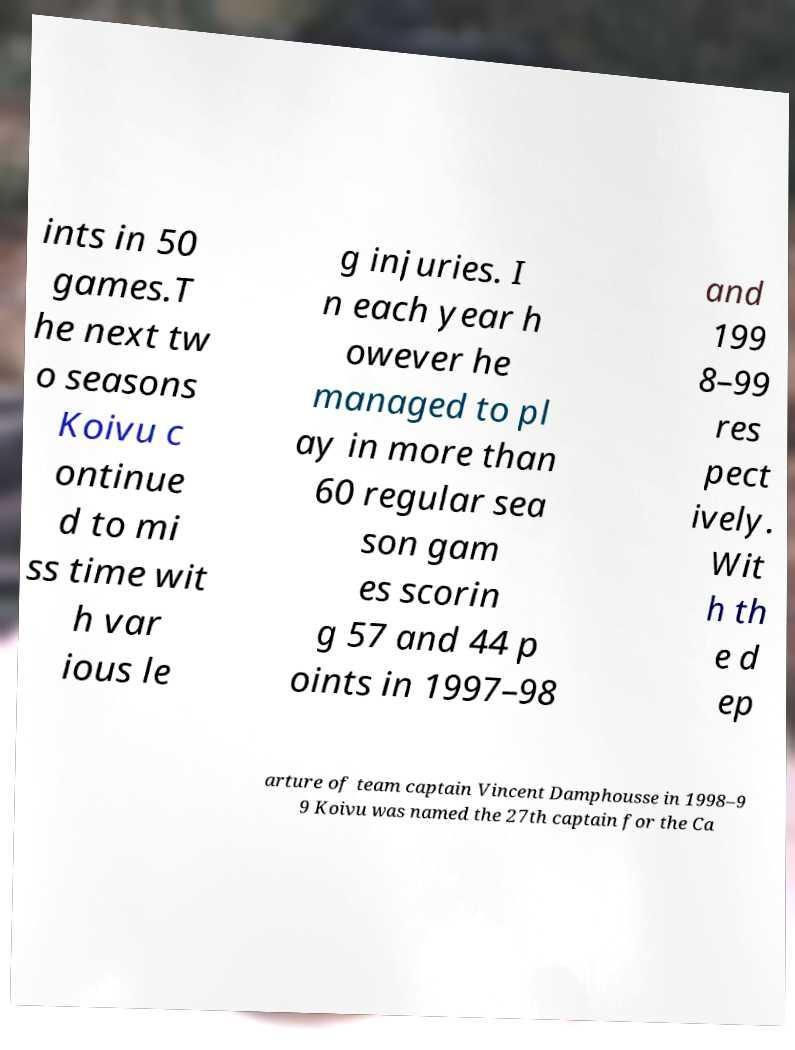What messages or text are displayed in this image? I need them in a readable, typed format. ints in 50 games.T he next tw o seasons Koivu c ontinue d to mi ss time wit h var ious le g injuries. I n each year h owever he managed to pl ay in more than 60 regular sea son gam es scorin g 57 and 44 p oints in 1997–98 and 199 8–99 res pect ively. Wit h th e d ep arture of team captain Vincent Damphousse in 1998–9 9 Koivu was named the 27th captain for the Ca 